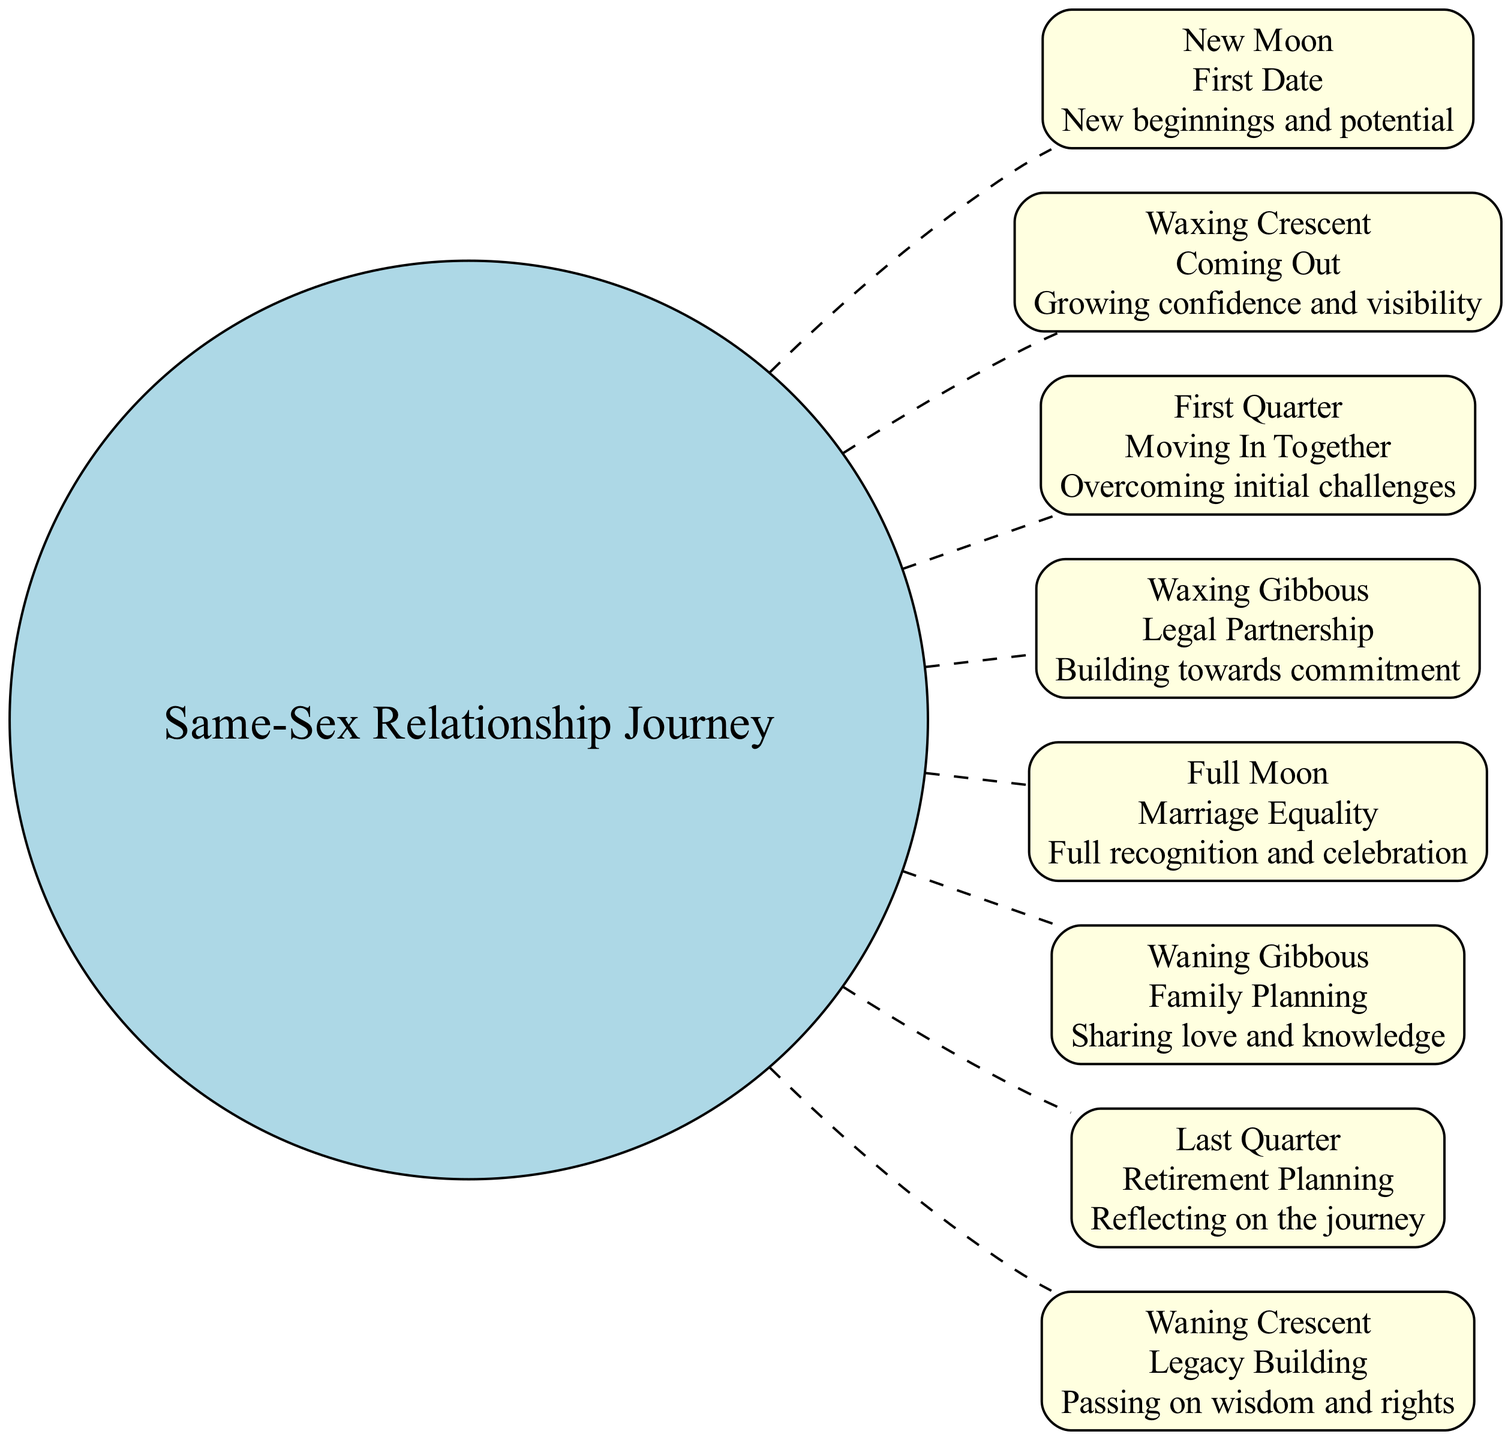What is the milestone associated with the Waxing Crescent phase? The Waxing Crescent phase corresponds to the milestone 'Coming Out' as indicated in the diagram.
Answer: Coming Out How many phases are represented in the diagram? The diagram features a total of eight phases, each depicting a significant milestone in the relationship journey.
Answer: 8 Which phase symbolizes full recognition and celebration? The Full Moon phase is symbolic of full recognition and celebration during the journey, as it represents 'Marriage Equality'.
Answer: Marriage Equality What is the symbolic meaning of the Last Quarter phase? The Last Quarter phase symbolizes reflecting on the journey, which aligns with the milestone of 'Retirement Planning'.
Answer: Reflecting on the journey In which phase do couples typically start family planning? Couples often begin family planning during the Waning Gibbous phase, which corresponds to this milestone and its symbolism of sharing love and knowledge.
Answer: Family Planning Which phase indicates the beginning of a same-sex couple's journey? The New Moon phase signifies the beginning of a same-sex couple's journey, corresponding to the milestone of 'First Date'.
Answer: First Date What is the relationship between the Waxing Gibbous phase and commitment? The Waxing Gibbous phase is associated with the milestone 'Legal Partnership', which symbolizes building towards commitment in the relationship.
Answer: Building towards commitment Which phase comes directly before the Full Moon phase? The phase that comes directly before the Full Moon phase is the Waxing Gibbous phase, as indicated by the arrangement of nodes in the diagram.
Answer: Waxing Gibbous 